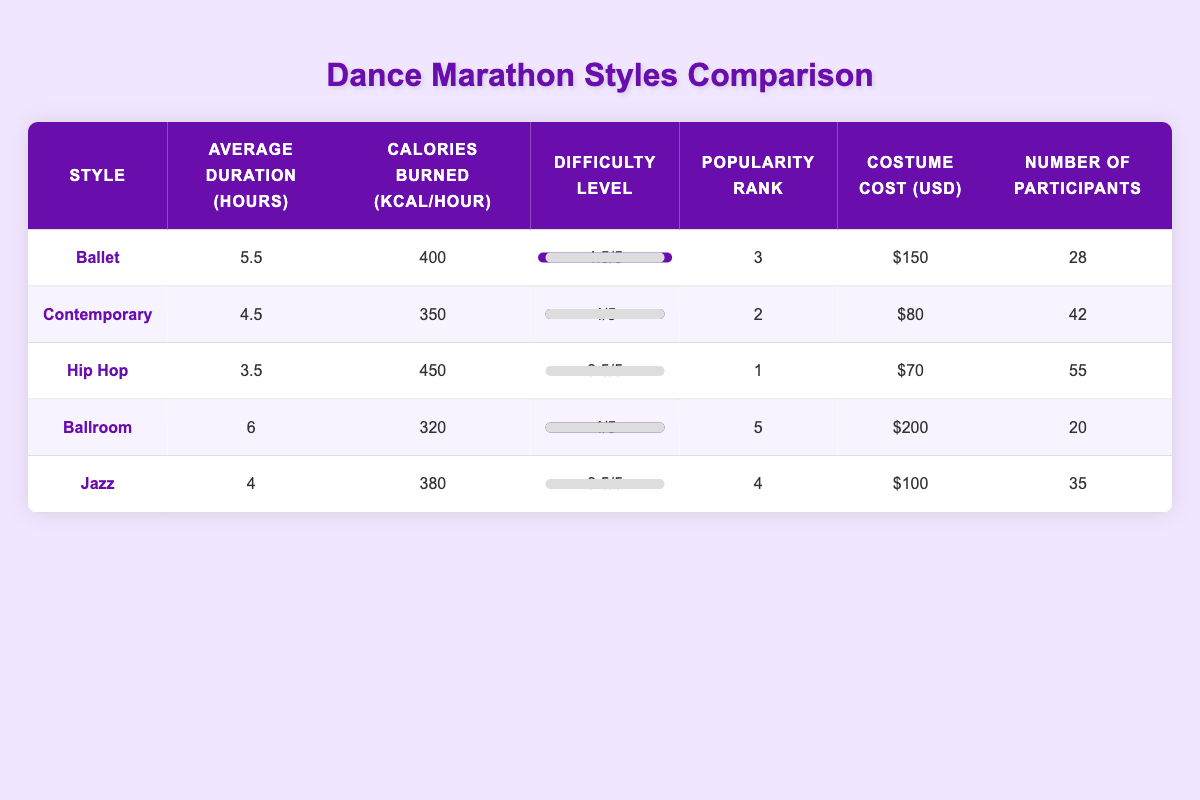What is the average duration for Jazz dance style? The average duration for Jazz dance style is directly listed in the table as 4 hours.
Answer: 4 hours Which dance style has the highest calories burned per hour? The table shows that Hip Hop has the highest calories burned per hour at 450 kcal.
Answer: Hip Hop How many more participants does Hip Hop have compared to Ballroom? The number of participants for Hip Hop is 55, while for Ballroom it is 20. To find the difference, subtract 20 from 55, which results in 35 more participants.
Answer: 35 more participants Is the costume cost for Contemporary lower than that of Jazz? The costume cost for Contemporary is $80 and for Jazz it is $100. Since $80 is less than $100, this statement is true.
Answer: Yes What is the total number of participants across all dance styles? The total number of participants can be found by adding all values from the "Number of Participants" column: 28 + 42 + 55 + 20 + 35 = 180. Therefore, the total number of participants is 180.
Answer: 180 Which dance style is ranked second in popularity and what is its average duration? The table indicates that the dance style ranked second in popularity is Contemporary, with an average duration of 4.5 hours.
Answer: Contemporary, 4.5 hours How do the difficulty levels compare between Ballet and Hip Hop? The table presents the difficulty level of Ballet as 4.5 and Hip Hop as 3.5. Compared to Hip Hop, Ballet is 1 point more difficult.
Answer: Ballet is more difficult by 1 point What is the average calorie burn per hour for the top three popular dance styles? The top three popular dance styles are Hip Hop, Contemporary, and Ballet with calorie burns of 450, 350, and 400 respectively. The average can be calculated by summing these values (450 + 350 + 400 = 1200) and dividing by 3, resulting in 1200 / 3 = 400.
Answer: 400 kcal/hour 